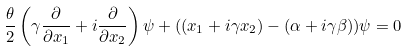Convert formula to latex. <formula><loc_0><loc_0><loc_500><loc_500>\frac { \theta } { 2 } \left ( \gamma \frac { \partial } { \partial x _ { 1 } } + i \frac { \partial } { \partial x _ { 2 } } \right ) \psi + ( ( x _ { 1 } + i \gamma x _ { 2 } ) - ( \alpha + i \gamma \beta ) ) \psi = 0</formula> 